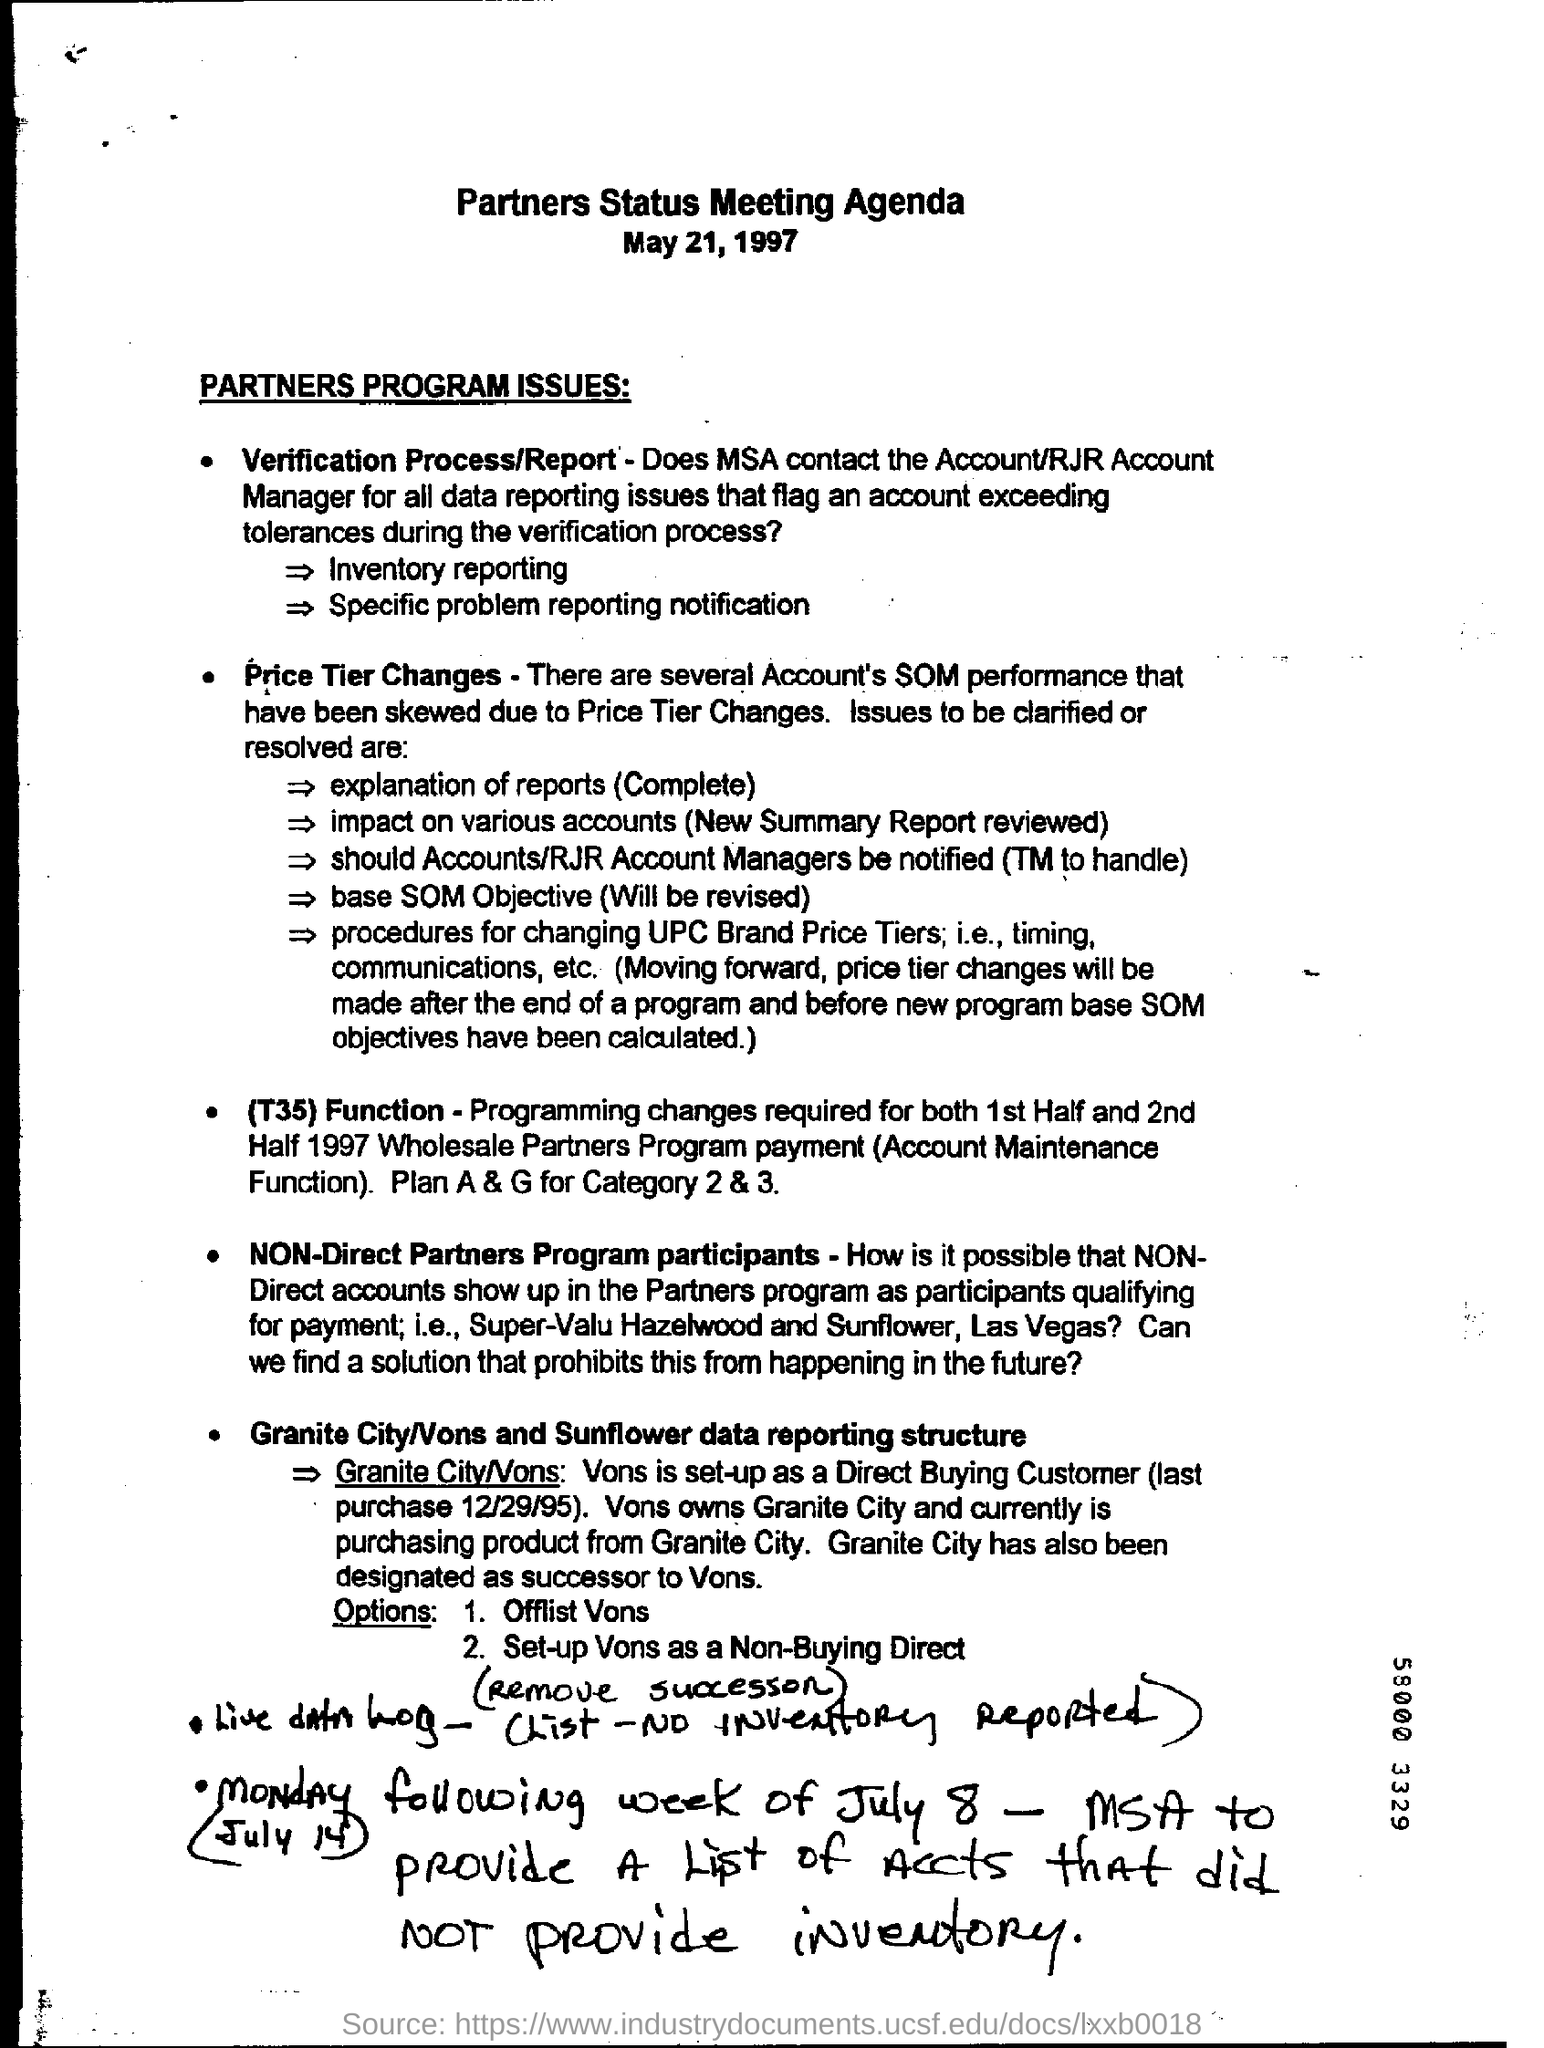Indicate a few pertinent items in this graphic. The document was dated May 21, 1997. 